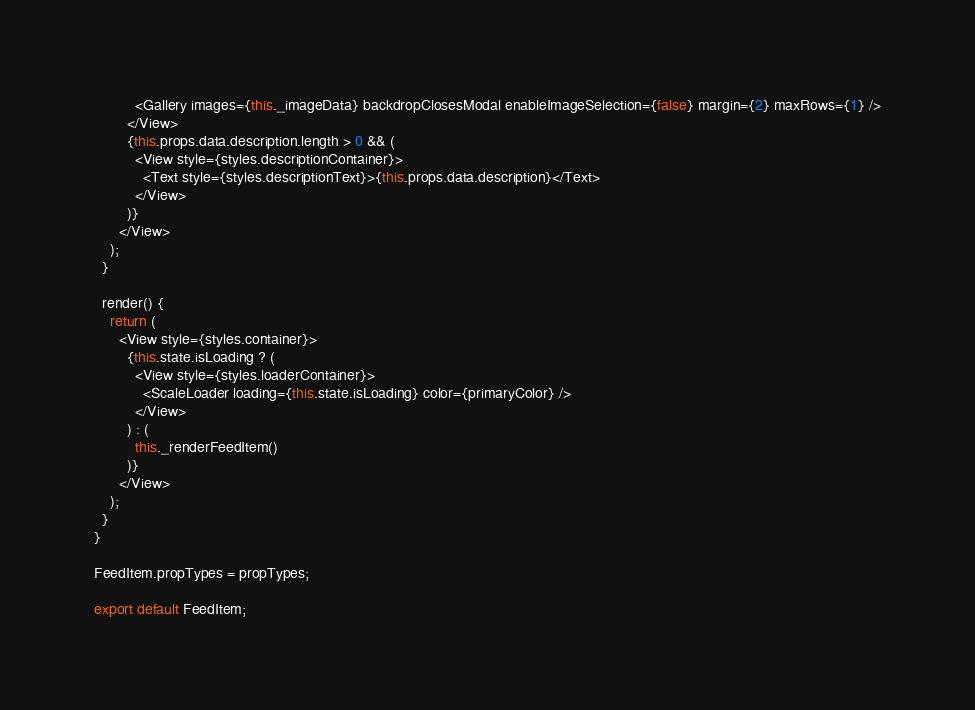Convert code to text. <code><loc_0><loc_0><loc_500><loc_500><_JavaScript_>          <Gallery images={this._imageData} backdropClosesModal enableImageSelection={false} margin={2} maxRows={1} />
        </View>
        {this.props.data.description.length > 0 && (
          <View style={styles.descriptionContainer}>
            <Text style={styles.descriptionText}>{this.props.data.description}</Text>
          </View>
        )}
      </View>
    );
  }

  render() {
    return (
      <View style={styles.container}>
        {this.state.isLoading ? (
          <View style={styles.loaderContainer}>
            <ScaleLoader loading={this.state.isLoading} color={primaryColor} />
          </View>
        ) : (
          this._renderFeedItem()
        )}
      </View>
    );
  }
}

FeedItem.propTypes = propTypes;

export default FeedItem;
</code> 